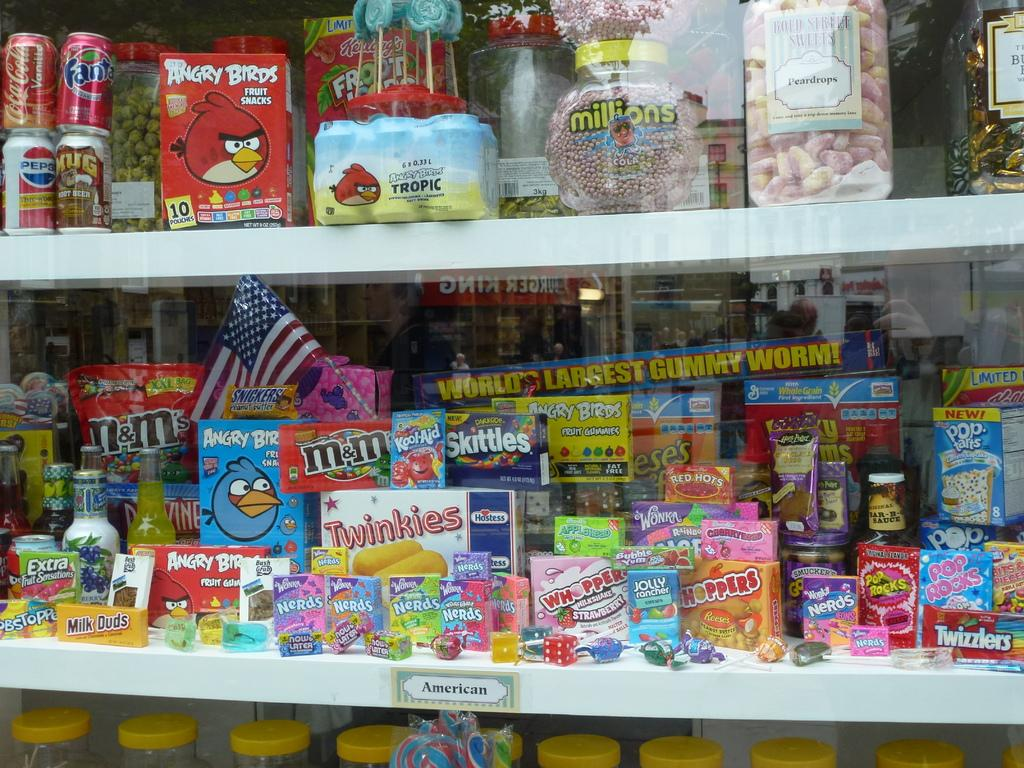<image>
Present a compact description of the photo's key features. a shelf with candies on it that is labeled 'american' 